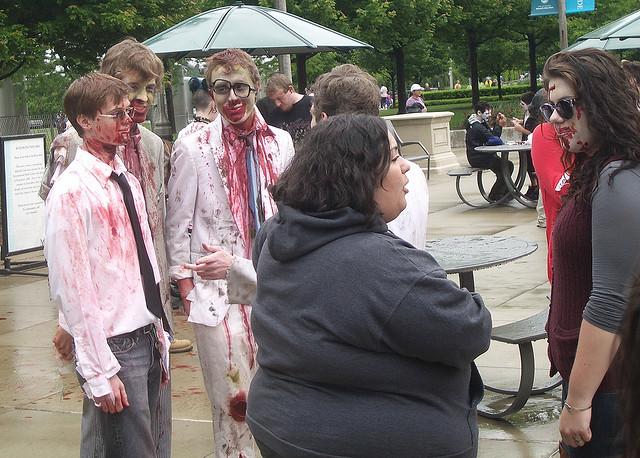Which woman is wearing sunglasses?
Keep it brief. Right. What substance is covering the white shirts in this photo?
Give a very brief answer. Blood. Is this outdoors?
Write a very short answer. Yes. 